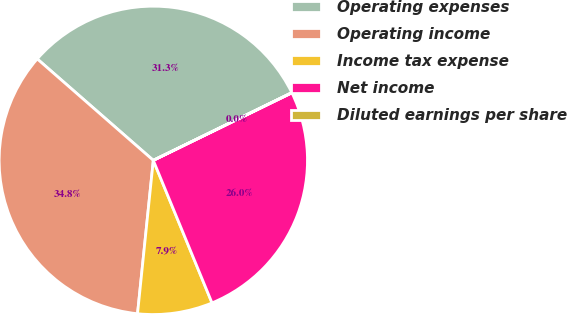Convert chart to OTSL. <chart><loc_0><loc_0><loc_500><loc_500><pie_chart><fcel>Operating expenses<fcel>Operating income<fcel>Income tax expense<fcel>Net income<fcel>Diluted earnings per share<nl><fcel>31.33%<fcel>34.8%<fcel>7.85%<fcel>26.0%<fcel>0.02%<nl></chart> 